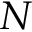<formula> <loc_0><loc_0><loc_500><loc_500>N</formula> 